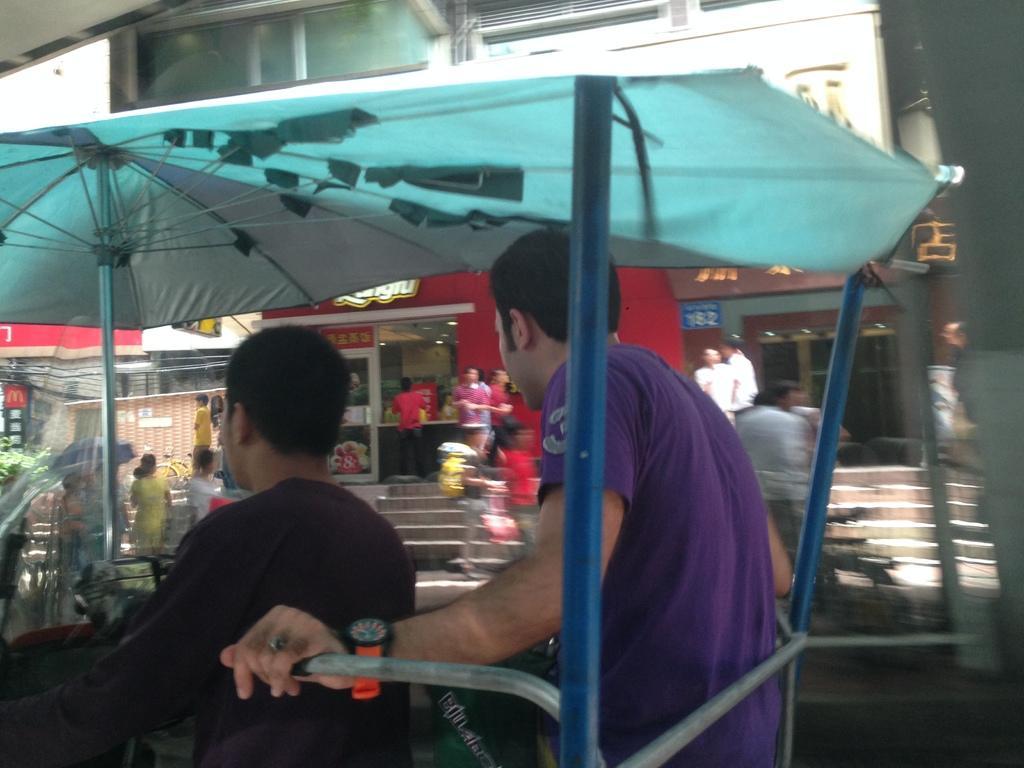How would you summarize this image in a sentence or two? In this image we can see the building, few shops, some objects on the ground, some objects in the shops, some objects attached to the shops, some trees, one staircase, one object looks like a vehicle, two umbrellas, one man sitting in the vehicle, some people are standing, some people are walking, some people are holding objects, one object on the top left side corner of the image, one road, the image is blurred, one object on the right side of the image, some boards with text and images. 